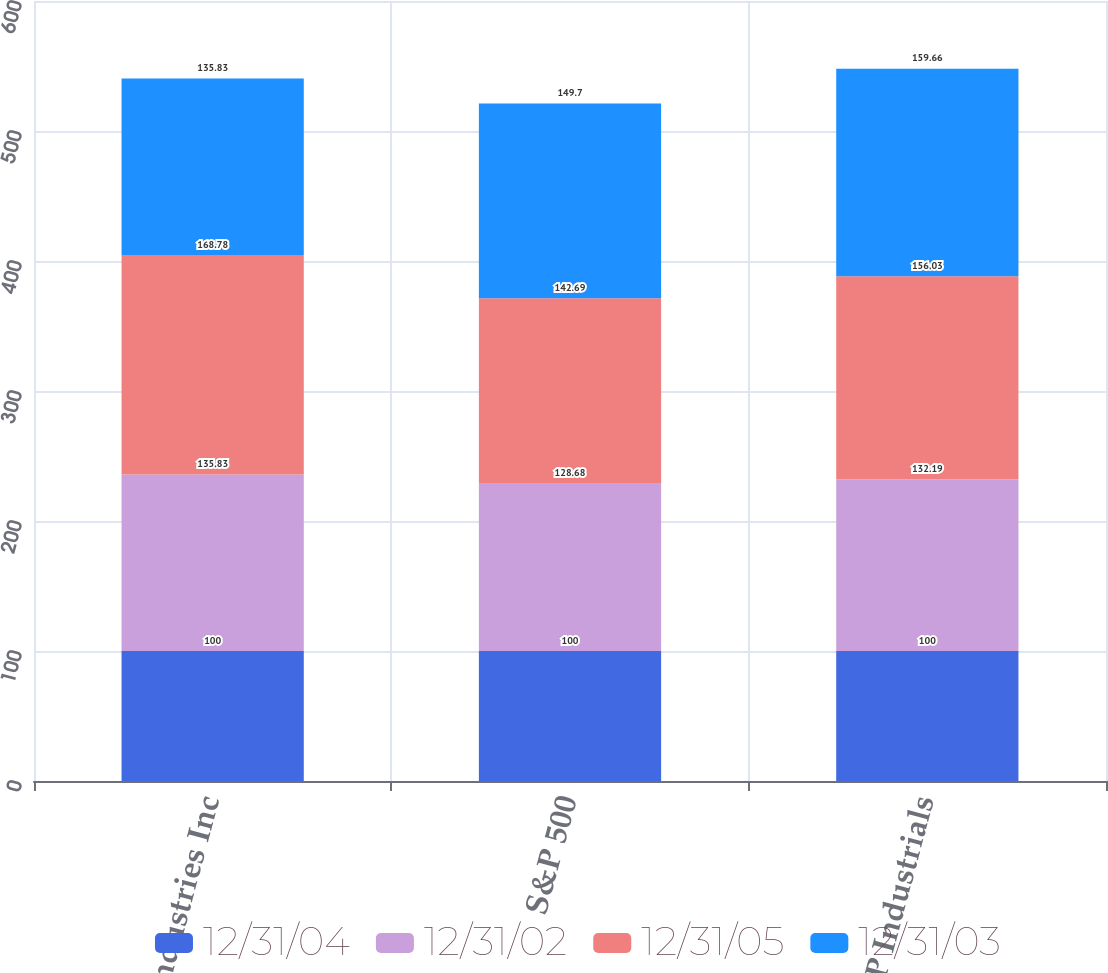Convert chart to OTSL. <chart><loc_0><loc_0><loc_500><loc_500><stacked_bar_chart><ecel><fcel>Roper Industries Inc<fcel>S&P 500<fcel>S&P Industrials<nl><fcel>12/31/04<fcel>100<fcel>100<fcel>100<nl><fcel>12/31/02<fcel>135.83<fcel>128.68<fcel>132.19<nl><fcel>12/31/05<fcel>168.78<fcel>142.69<fcel>156.03<nl><fcel>12/31/03<fcel>135.83<fcel>149.7<fcel>159.66<nl></chart> 